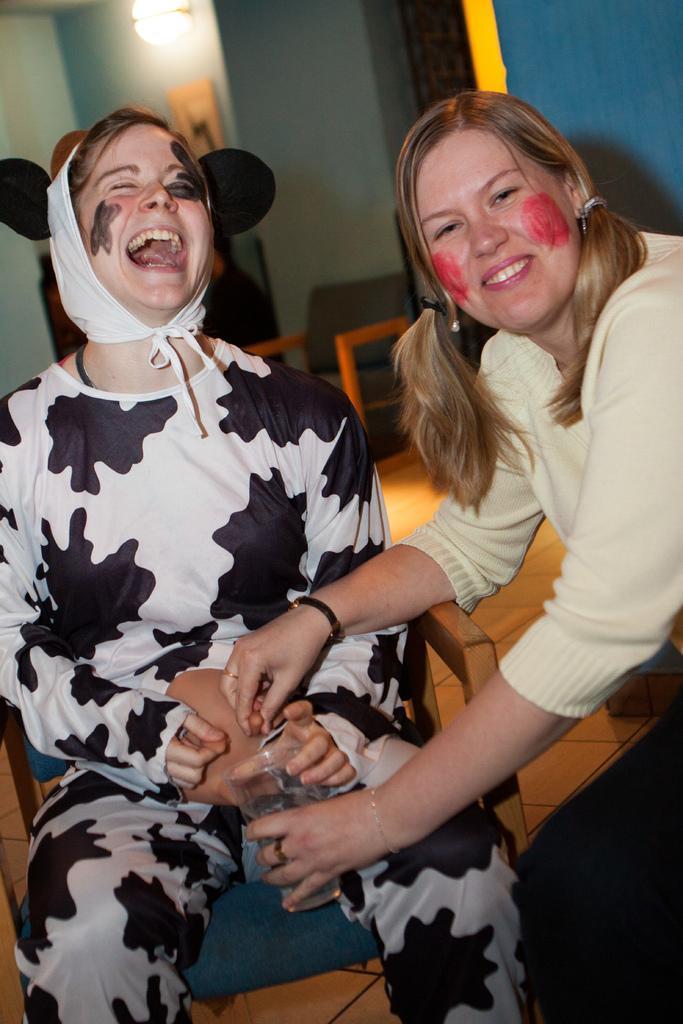Could you give a brief overview of what you see in this image? In the center of the image we can see two ladies sitting. The lady sitting on the right is holding a glass in her hand. In the background there are walls, chair and light. 